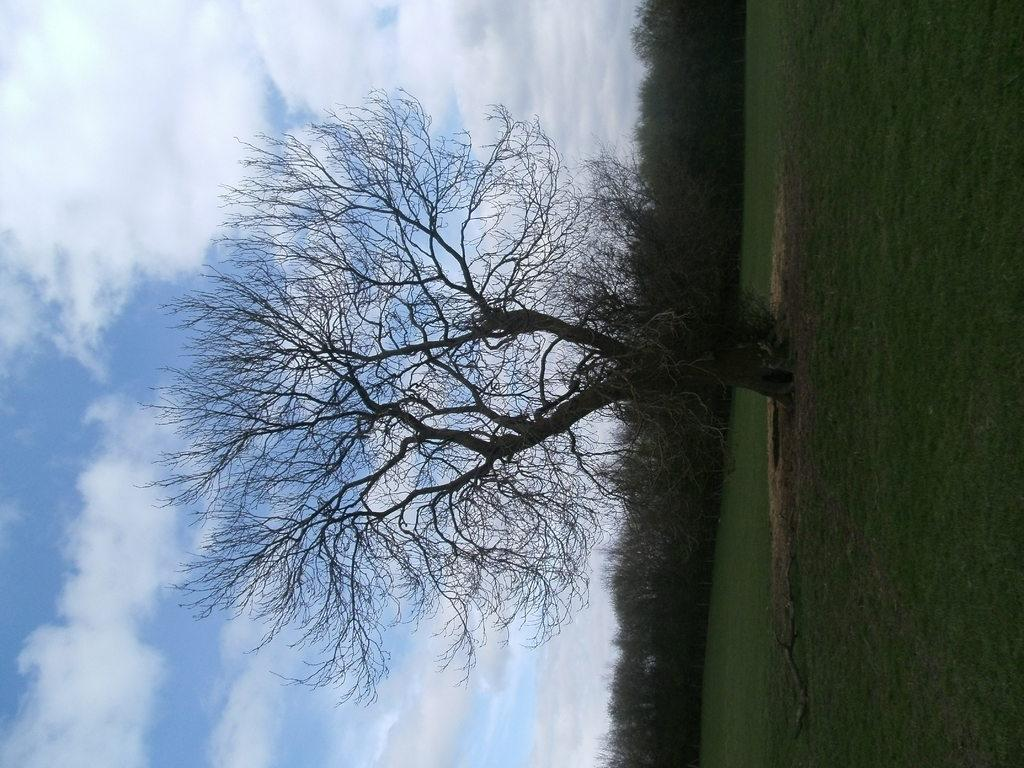What type of vegetation is present on the ground in the image? There is grass on the ground in the image. What other natural elements can be seen in the image? There are trees in the image. What is the condition of the sky in the image? The sky is cloudy in the image. What time is displayed on the watch in the image? There is no watch present in the image. What type of horn can be seen on the animal in the image? There are no animals or horns present in the image. 